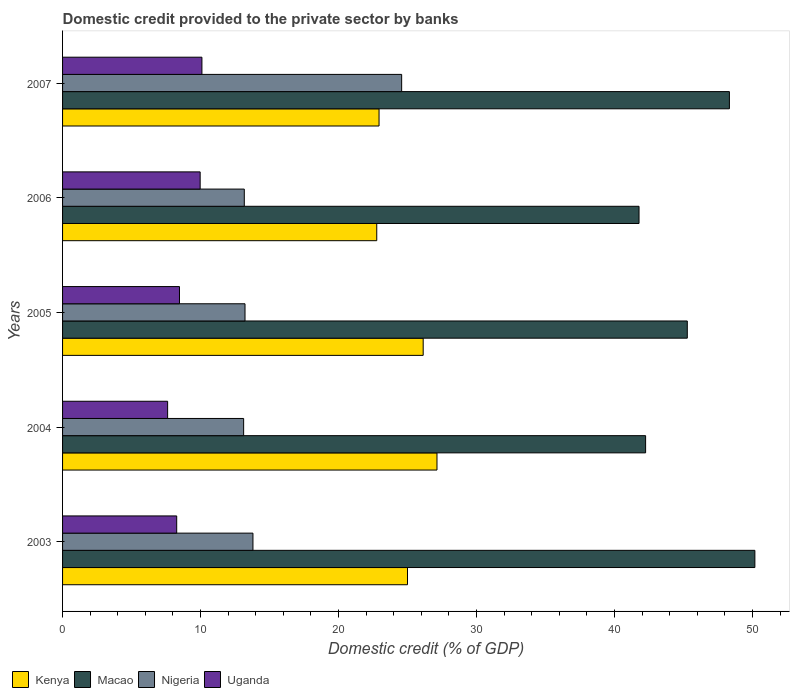How many bars are there on the 3rd tick from the top?
Ensure brevity in your answer.  4. How many bars are there on the 5th tick from the bottom?
Your answer should be very brief. 4. What is the domestic credit provided to the private sector by banks in Macao in 2004?
Ensure brevity in your answer.  42.25. Across all years, what is the maximum domestic credit provided to the private sector by banks in Macao?
Provide a succinct answer. 50.17. Across all years, what is the minimum domestic credit provided to the private sector by banks in Uganda?
Offer a terse response. 7.61. What is the total domestic credit provided to the private sector by banks in Nigeria in the graph?
Provide a succinct answer. 77.88. What is the difference between the domestic credit provided to the private sector by banks in Kenya in 2003 and that in 2005?
Offer a terse response. -1.14. What is the difference between the domestic credit provided to the private sector by banks in Uganda in 2006 and the domestic credit provided to the private sector by banks in Nigeria in 2007?
Your answer should be compact. -14.6. What is the average domestic credit provided to the private sector by banks in Nigeria per year?
Offer a terse response. 15.58. In the year 2004, what is the difference between the domestic credit provided to the private sector by banks in Nigeria and domestic credit provided to the private sector by banks in Kenya?
Provide a short and direct response. -14.01. In how many years, is the domestic credit provided to the private sector by banks in Kenya greater than 42 %?
Your answer should be compact. 0. What is the ratio of the domestic credit provided to the private sector by banks in Nigeria in 2005 to that in 2007?
Your answer should be compact. 0.54. What is the difference between the highest and the second highest domestic credit provided to the private sector by banks in Kenya?
Ensure brevity in your answer.  1. What is the difference between the highest and the lowest domestic credit provided to the private sector by banks in Uganda?
Provide a succinct answer. 2.49. In how many years, is the domestic credit provided to the private sector by banks in Kenya greater than the average domestic credit provided to the private sector by banks in Kenya taken over all years?
Your answer should be compact. 3. Is the sum of the domestic credit provided to the private sector by banks in Macao in 2005 and 2006 greater than the maximum domestic credit provided to the private sector by banks in Kenya across all years?
Keep it short and to the point. Yes. What does the 2nd bar from the top in 2003 represents?
Offer a terse response. Nigeria. What does the 3rd bar from the bottom in 2005 represents?
Your answer should be very brief. Nigeria. Is it the case that in every year, the sum of the domestic credit provided to the private sector by banks in Kenya and domestic credit provided to the private sector by banks in Uganda is greater than the domestic credit provided to the private sector by banks in Nigeria?
Offer a terse response. Yes. Are all the bars in the graph horizontal?
Provide a short and direct response. Yes. How many years are there in the graph?
Offer a terse response. 5. What is the difference between two consecutive major ticks on the X-axis?
Keep it short and to the point. 10. Does the graph contain grids?
Make the answer very short. No. How many legend labels are there?
Give a very brief answer. 4. How are the legend labels stacked?
Offer a very short reply. Horizontal. What is the title of the graph?
Make the answer very short. Domestic credit provided to the private sector by banks. What is the label or title of the X-axis?
Provide a succinct answer. Domestic credit (% of GDP). What is the Domestic credit (% of GDP) of Kenya in 2003?
Give a very brief answer. 24.99. What is the Domestic credit (% of GDP) in Macao in 2003?
Keep it short and to the point. 50.17. What is the Domestic credit (% of GDP) in Nigeria in 2003?
Offer a terse response. 13.8. What is the Domestic credit (% of GDP) in Uganda in 2003?
Your answer should be very brief. 8.27. What is the Domestic credit (% of GDP) of Kenya in 2004?
Offer a very short reply. 27.13. What is the Domestic credit (% of GDP) of Macao in 2004?
Ensure brevity in your answer.  42.25. What is the Domestic credit (% of GDP) of Nigeria in 2004?
Keep it short and to the point. 13.12. What is the Domestic credit (% of GDP) in Uganda in 2004?
Your answer should be very brief. 7.61. What is the Domestic credit (% of GDP) in Kenya in 2005?
Provide a short and direct response. 26.13. What is the Domestic credit (% of GDP) in Macao in 2005?
Ensure brevity in your answer.  45.27. What is the Domestic credit (% of GDP) in Nigeria in 2005?
Your answer should be compact. 13.22. What is the Domestic credit (% of GDP) of Uganda in 2005?
Give a very brief answer. 8.47. What is the Domestic credit (% of GDP) of Kenya in 2006?
Your answer should be very brief. 22.77. What is the Domestic credit (% of GDP) of Macao in 2006?
Your answer should be compact. 41.77. What is the Domestic credit (% of GDP) of Nigeria in 2006?
Make the answer very short. 13.17. What is the Domestic credit (% of GDP) of Uganda in 2006?
Keep it short and to the point. 9.97. What is the Domestic credit (% of GDP) of Kenya in 2007?
Keep it short and to the point. 22.93. What is the Domestic credit (% of GDP) of Macao in 2007?
Give a very brief answer. 48.32. What is the Domestic credit (% of GDP) in Nigeria in 2007?
Your response must be concise. 24.57. What is the Domestic credit (% of GDP) of Uganda in 2007?
Offer a terse response. 10.1. Across all years, what is the maximum Domestic credit (% of GDP) of Kenya?
Ensure brevity in your answer.  27.13. Across all years, what is the maximum Domestic credit (% of GDP) in Macao?
Provide a short and direct response. 50.17. Across all years, what is the maximum Domestic credit (% of GDP) of Nigeria?
Make the answer very short. 24.57. Across all years, what is the maximum Domestic credit (% of GDP) of Uganda?
Provide a succinct answer. 10.1. Across all years, what is the minimum Domestic credit (% of GDP) in Kenya?
Provide a succinct answer. 22.77. Across all years, what is the minimum Domestic credit (% of GDP) of Macao?
Offer a very short reply. 41.77. Across all years, what is the minimum Domestic credit (% of GDP) of Nigeria?
Your response must be concise. 13.12. Across all years, what is the minimum Domestic credit (% of GDP) in Uganda?
Provide a succinct answer. 7.61. What is the total Domestic credit (% of GDP) of Kenya in the graph?
Provide a succinct answer. 123.96. What is the total Domestic credit (% of GDP) in Macao in the graph?
Offer a terse response. 227.78. What is the total Domestic credit (% of GDP) of Nigeria in the graph?
Your response must be concise. 77.88. What is the total Domestic credit (% of GDP) in Uganda in the graph?
Provide a short and direct response. 44.42. What is the difference between the Domestic credit (% of GDP) of Kenya in 2003 and that in 2004?
Keep it short and to the point. -2.14. What is the difference between the Domestic credit (% of GDP) of Macao in 2003 and that in 2004?
Your answer should be very brief. 7.92. What is the difference between the Domestic credit (% of GDP) in Nigeria in 2003 and that in 2004?
Offer a very short reply. 0.68. What is the difference between the Domestic credit (% of GDP) in Uganda in 2003 and that in 2004?
Offer a very short reply. 0.66. What is the difference between the Domestic credit (% of GDP) in Kenya in 2003 and that in 2005?
Give a very brief answer. -1.14. What is the difference between the Domestic credit (% of GDP) of Macao in 2003 and that in 2005?
Your response must be concise. 4.9. What is the difference between the Domestic credit (% of GDP) of Nigeria in 2003 and that in 2005?
Your answer should be compact. 0.58. What is the difference between the Domestic credit (% of GDP) in Uganda in 2003 and that in 2005?
Provide a succinct answer. -0.2. What is the difference between the Domestic credit (% of GDP) in Kenya in 2003 and that in 2006?
Your response must be concise. 2.23. What is the difference between the Domestic credit (% of GDP) in Macao in 2003 and that in 2006?
Keep it short and to the point. 8.39. What is the difference between the Domestic credit (% of GDP) in Nigeria in 2003 and that in 2006?
Ensure brevity in your answer.  0.63. What is the difference between the Domestic credit (% of GDP) in Uganda in 2003 and that in 2006?
Make the answer very short. -1.7. What is the difference between the Domestic credit (% of GDP) of Kenya in 2003 and that in 2007?
Make the answer very short. 2.06. What is the difference between the Domestic credit (% of GDP) of Macao in 2003 and that in 2007?
Provide a short and direct response. 1.85. What is the difference between the Domestic credit (% of GDP) in Nigeria in 2003 and that in 2007?
Give a very brief answer. -10.78. What is the difference between the Domestic credit (% of GDP) of Uganda in 2003 and that in 2007?
Ensure brevity in your answer.  -1.83. What is the difference between the Domestic credit (% of GDP) in Macao in 2004 and that in 2005?
Your answer should be very brief. -3.02. What is the difference between the Domestic credit (% of GDP) of Nigeria in 2004 and that in 2005?
Offer a terse response. -0.1. What is the difference between the Domestic credit (% of GDP) of Uganda in 2004 and that in 2005?
Keep it short and to the point. -0.86. What is the difference between the Domestic credit (% of GDP) of Kenya in 2004 and that in 2006?
Make the answer very short. 4.36. What is the difference between the Domestic credit (% of GDP) in Macao in 2004 and that in 2006?
Your response must be concise. 0.48. What is the difference between the Domestic credit (% of GDP) in Nigeria in 2004 and that in 2006?
Provide a succinct answer. -0.05. What is the difference between the Domestic credit (% of GDP) of Uganda in 2004 and that in 2006?
Give a very brief answer. -2.36. What is the difference between the Domestic credit (% of GDP) of Kenya in 2004 and that in 2007?
Provide a succinct answer. 4.2. What is the difference between the Domestic credit (% of GDP) in Macao in 2004 and that in 2007?
Your answer should be compact. -6.07. What is the difference between the Domestic credit (% of GDP) of Nigeria in 2004 and that in 2007?
Your answer should be very brief. -11.45. What is the difference between the Domestic credit (% of GDP) in Uganda in 2004 and that in 2007?
Provide a short and direct response. -2.49. What is the difference between the Domestic credit (% of GDP) in Kenya in 2005 and that in 2006?
Keep it short and to the point. 3.36. What is the difference between the Domestic credit (% of GDP) in Macao in 2005 and that in 2006?
Make the answer very short. 3.5. What is the difference between the Domestic credit (% of GDP) in Nigeria in 2005 and that in 2006?
Offer a very short reply. 0.05. What is the difference between the Domestic credit (% of GDP) in Uganda in 2005 and that in 2006?
Your answer should be very brief. -1.5. What is the difference between the Domestic credit (% of GDP) in Kenya in 2005 and that in 2007?
Give a very brief answer. 3.2. What is the difference between the Domestic credit (% of GDP) of Macao in 2005 and that in 2007?
Offer a very short reply. -3.05. What is the difference between the Domestic credit (% of GDP) in Nigeria in 2005 and that in 2007?
Offer a very short reply. -11.35. What is the difference between the Domestic credit (% of GDP) in Uganda in 2005 and that in 2007?
Offer a terse response. -1.63. What is the difference between the Domestic credit (% of GDP) of Kenya in 2006 and that in 2007?
Give a very brief answer. -0.17. What is the difference between the Domestic credit (% of GDP) of Macao in 2006 and that in 2007?
Your answer should be very brief. -6.55. What is the difference between the Domestic credit (% of GDP) of Nigeria in 2006 and that in 2007?
Your answer should be compact. -11.4. What is the difference between the Domestic credit (% of GDP) in Uganda in 2006 and that in 2007?
Ensure brevity in your answer.  -0.13. What is the difference between the Domestic credit (% of GDP) of Kenya in 2003 and the Domestic credit (% of GDP) of Macao in 2004?
Your answer should be very brief. -17.25. What is the difference between the Domestic credit (% of GDP) in Kenya in 2003 and the Domestic credit (% of GDP) in Nigeria in 2004?
Offer a very short reply. 11.87. What is the difference between the Domestic credit (% of GDP) of Kenya in 2003 and the Domestic credit (% of GDP) of Uganda in 2004?
Ensure brevity in your answer.  17.38. What is the difference between the Domestic credit (% of GDP) in Macao in 2003 and the Domestic credit (% of GDP) in Nigeria in 2004?
Make the answer very short. 37.05. What is the difference between the Domestic credit (% of GDP) in Macao in 2003 and the Domestic credit (% of GDP) in Uganda in 2004?
Offer a terse response. 42.55. What is the difference between the Domestic credit (% of GDP) of Nigeria in 2003 and the Domestic credit (% of GDP) of Uganda in 2004?
Give a very brief answer. 6.18. What is the difference between the Domestic credit (% of GDP) of Kenya in 2003 and the Domestic credit (% of GDP) of Macao in 2005?
Provide a succinct answer. -20.28. What is the difference between the Domestic credit (% of GDP) of Kenya in 2003 and the Domestic credit (% of GDP) of Nigeria in 2005?
Offer a terse response. 11.77. What is the difference between the Domestic credit (% of GDP) in Kenya in 2003 and the Domestic credit (% of GDP) in Uganda in 2005?
Your answer should be very brief. 16.52. What is the difference between the Domestic credit (% of GDP) in Macao in 2003 and the Domestic credit (% of GDP) in Nigeria in 2005?
Your answer should be compact. 36.95. What is the difference between the Domestic credit (% of GDP) in Macao in 2003 and the Domestic credit (% of GDP) in Uganda in 2005?
Ensure brevity in your answer.  41.69. What is the difference between the Domestic credit (% of GDP) in Nigeria in 2003 and the Domestic credit (% of GDP) in Uganda in 2005?
Keep it short and to the point. 5.32. What is the difference between the Domestic credit (% of GDP) of Kenya in 2003 and the Domestic credit (% of GDP) of Macao in 2006?
Provide a short and direct response. -16.78. What is the difference between the Domestic credit (% of GDP) in Kenya in 2003 and the Domestic credit (% of GDP) in Nigeria in 2006?
Provide a short and direct response. 11.83. What is the difference between the Domestic credit (% of GDP) in Kenya in 2003 and the Domestic credit (% of GDP) in Uganda in 2006?
Make the answer very short. 15.02. What is the difference between the Domestic credit (% of GDP) in Macao in 2003 and the Domestic credit (% of GDP) in Nigeria in 2006?
Provide a succinct answer. 37. What is the difference between the Domestic credit (% of GDP) of Macao in 2003 and the Domestic credit (% of GDP) of Uganda in 2006?
Provide a short and direct response. 40.2. What is the difference between the Domestic credit (% of GDP) of Nigeria in 2003 and the Domestic credit (% of GDP) of Uganda in 2006?
Your answer should be very brief. 3.83. What is the difference between the Domestic credit (% of GDP) of Kenya in 2003 and the Domestic credit (% of GDP) of Macao in 2007?
Provide a short and direct response. -23.33. What is the difference between the Domestic credit (% of GDP) in Kenya in 2003 and the Domestic credit (% of GDP) in Nigeria in 2007?
Ensure brevity in your answer.  0.42. What is the difference between the Domestic credit (% of GDP) of Kenya in 2003 and the Domestic credit (% of GDP) of Uganda in 2007?
Ensure brevity in your answer.  14.9. What is the difference between the Domestic credit (% of GDP) in Macao in 2003 and the Domestic credit (% of GDP) in Nigeria in 2007?
Your answer should be compact. 25.6. What is the difference between the Domestic credit (% of GDP) of Macao in 2003 and the Domestic credit (% of GDP) of Uganda in 2007?
Your answer should be compact. 40.07. What is the difference between the Domestic credit (% of GDP) of Nigeria in 2003 and the Domestic credit (% of GDP) of Uganda in 2007?
Ensure brevity in your answer.  3.7. What is the difference between the Domestic credit (% of GDP) of Kenya in 2004 and the Domestic credit (% of GDP) of Macao in 2005?
Provide a succinct answer. -18.14. What is the difference between the Domestic credit (% of GDP) in Kenya in 2004 and the Domestic credit (% of GDP) in Nigeria in 2005?
Keep it short and to the point. 13.91. What is the difference between the Domestic credit (% of GDP) of Kenya in 2004 and the Domestic credit (% of GDP) of Uganda in 2005?
Offer a terse response. 18.66. What is the difference between the Domestic credit (% of GDP) in Macao in 2004 and the Domestic credit (% of GDP) in Nigeria in 2005?
Offer a terse response. 29.03. What is the difference between the Domestic credit (% of GDP) of Macao in 2004 and the Domestic credit (% of GDP) of Uganda in 2005?
Make the answer very short. 33.78. What is the difference between the Domestic credit (% of GDP) of Nigeria in 2004 and the Domestic credit (% of GDP) of Uganda in 2005?
Offer a very short reply. 4.65. What is the difference between the Domestic credit (% of GDP) of Kenya in 2004 and the Domestic credit (% of GDP) of Macao in 2006?
Your answer should be very brief. -14.64. What is the difference between the Domestic credit (% of GDP) of Kenya in 2004 and the Domestic credit (% of GDP) of Nigeria in 2006?
Your answer should be very brief. 13.96. What is the difference between the Domestic credit (% of GDP) in Kenya in 2004 and the Domestic credit (% of GDP) in Uganda in 2006?
Your answer should be very brief. 17.16. What is the difference between the Domestic credit (% of GDP) of Macao in 2004 and the Domestic credit (% of GDP) of Nigeria in 2006?
Keep it short and to the point. 29.08. What is the difference between the Domestic credit (% of GDP) in Macao in 2004 and the Domestic credit (% of GDP) in Uganda in 2006?
Provide a short and direct response. 32.28. What is the difference between the Domestic credit (% of GDP) of Nigeria in 2004 and the Domestic credit (% of GDP) of Uganda in 2006?
Provide a succinct answer. 3.15. What is the difference between the Domestic credit (% of GDP) in Kenya in 2004 and the Domestic credit (% of GDP) in Macao in 2007?
Make the answer very short. -21.19. What is the difference between the Domestic credit (% of GDP) of Kenya in 2004 and the Domestic credit (% of GDP) of Nigeria in 2007?
Keep it short and to the point. 2.56. What is the difference between the Domestic credit (% of GDP) of Kenya in 2004 and the Domestic credit (% of GDP) of Uganda in 2007?
Your answer should be compact. 17.03. What is the difference between the Domestic credit (% of GDP) of Macao in 2004 and the Domestic credit (% of GDP) of Nigeria in 2007?
Offer a very short reply. 17.68. What is the difference between the Domestic credit (% of GDP) in Macao in 2004 and the Domestic credit (% of GDP) in Uganda in 2007?
Provide a succinct answer. 32.15. What is the difference between the Domestic credit (% of GDP) of Nigeria in 2004 and the Domestic credit (% of GDP) of Uganda in 2007?
Your answer should be compact. 3.02. What is the difference between the Domestic credit (% of GDP) of Kenya in 2005 and the Domestic credit (% of GDP) of Macao in 2006?
Give a very brief answer. -15.64. What is the difference between the Domestic credit (% of GDP) of Kenya in 2005 and the Domestic credit (% of GDP) of Nigeria in 2006?
Offer a very short reply. 12.96. What is the difference between the Domestic credit (% of GDP) in Kenya in 2005 and the Domestic credit (% of GDP) in Uganda in 2006?
Ensure brevity in your answer.  16.16. What is the difference between the Domestic credit (% of GDP) in Macao in 2005 and the Domestic credit (% of GDP) in Nigeria in 2006?
Offer a very short reply. 32.1. What is the difference between the Domestic credit (% of GDP) in Macao in 2005 and the Domestic credit (% of GDP) in Uganda in 2006?
Provide a succinct answer. 35.3. What is the difference between the Domestic credit (% of GDP) in Nigeria in 2005 and the Domestic credit (% of GDP) in Uganda in 2006?
Offer a terse response. 3.25. What is the difference between the Domestic credit (% of GDP) of Kenya in 2005 and the Domestic credit (% of GDP) of Macao in 2007?
Provide a succinct answer. -22.19. What is the difference between the Domestic credit (% of GDP) of Kenya in 2005 and the Domestic credit (% of GDP) of Nigeria in 2007?
Your answer should be very brief. 1.56. What is the difference between the Domestic credit (% of GDP) in Kenya in 2005 and the Domestic credit (% of GDP) in Uganda in 2007?
Offer a terse response. 16.03. What is the difference between the Domestic credit (% of GDP) of Macao in 2005 and the Domestic credit (% of GDP) of Nigeria in 2007?
Give a very brief answer. 20.7. What is the difference between the Domestic credit (% of GDP) of Macao in 2005 and the Domestic credit (% of GDP) of Uganda in 2007?
Provide a short and direct response. 35.17. What is the difference between the Domestic credit (% of GDP) of Nigeria in 2005 and the Domestic credit (% of GDP) of Uganda in 2007?
Provide a short and direct response. 3.12. What is the difference between the Domestic credit (% of GDP) of Kenya in 2006 and the Domestic credit (% of GDP) of Macao in 2007?
Offer a terse response. -25.55. What is the difference between the Domestic credit (% of GDP) of Kenya in 2006 and the Domestic credit (% of GDP) of Nigeria in 2007?
Make the answer very short. -1.8. What is the difference between the Domestic credit (% of GDP) in Kenya in 2006 and the Domestic credit (% of GDP) in Uganda in 2007?
Ensure brevity in your answer.  12.67. What is the difference between the Domestic credit (% of GDP) in Macao in 2006 and the Domestic credit (% of GDP) in Nigeria in 2007?
Your answer should be compact. 17.2. What is the difference between the Domestic credit (% of GDP) in Macao in 2006 and the Domestic credit (% of GDP) in Uganda in 2007?
Keep it short and to the point. 31.67. What is the difference between the Domestic credit (% of GDP) in Nigeria in 2006 and the Domestic credit (% of GDP) in Uganda in 2007?
Provide a succinct answer. 3.07. What is the average Domestic credit (% of GDP) of Kenya per year?
Provide a short and direct response. 24.79. What is the average Domestic credit (% of GDP) of Macao per year?
Give a very brief answer. 45.56. What is the average Domestic credit (% of GDP) of Nigeria per year?
Provide a short and direct response. 15.58. What is the average Domestic credit (% of GDP) of Uganda per year?
Offer a very short reply. 8.88. In the year 2003, what is the difference between the Domestic credit (% of GDP) of Kenya and Domestic credit (% of GDP) of Macao?
Make the answer very short. -25.17. In the year 2003, what is the difference between the Domestic credit (% of GDP) of Kenya and Domestic credit (% of GDP) of Nigeria?
Ensure brevity in your answer.  11.2. In the year 2003, what is the difference between the Domestic credit (% of GDP) of Kenya and Domestic credit (% of GDP) of Uganda?
Give a very brief answer. 16.72. In the year 2003, what is the difference between the Domestic credit (% of GDP) in Macao and Domestic credit (% of GDP) in Nigeria?
Ensure brevity in your answer.  36.37. In the year 2003, what is the difference between the Domestic credit (% of GDP) in Macao and Domestic credit (% of GDP) in Uganda?
Ensure brevity in your answer.  41.9. In the year 2003, what is the difference between the Domestic credit (% of GDP) of Nigeria and Domestic credit (% of GDP) of Uganda?
Make the answer very short. 5.53. In the year 2004, what is the difference between the Domestic credit (% of GDP) of Kenya and Domestic credit (% of GDP) of Macao?
Offer a very short reply. -15.12. In the year 2004, what is the difference between the Domestic credit (% of GDP) in Kenya and Domestic credit (% of GDP) in Nigeria?
Offer a terse response. 14.01. In the year 2004, what is the difference between the Domestic credit (% of GDP) in Kenya and Domestic credit (% of GDP) in Uganda?
Keep it short and to the point. 19.52. In the year 2004, what is the difference between the Domestic credit (% of GDP) in Macao and Domestic credit (% of GDP) in Nigeria?
Your answer should be very brief. 29.13. In the year 2004, what is the difference between the Domestic credit (% of GDP) in Macao and Domestic credit (% of GDP) in Uganda?
Ensure brevity in your answer.  34.64. In the year 2004, what is the difference between the Domestic credit (% of GDP) in Nigeria and Domestic credit (% of GDP) in Uganda?
Provide a short and direct response. 5.51. In the year 2005, what is the difference between the Domestic credit (% of GDP) of Kenya and Domestic credit (% of GDP) of Macao?
Provide a short and direct response. -19.14. In the year 2005, what is the difference between the Domestic credit (% of GDP) of Kenya and Domestic credit (% of GDP) of Nigeria?
Your response must be concise. 12.91. In the year 2005, what is the difference between the Domestic credit (% of GDP) of Kenya and Domestic credit (% of GDP) of Uganda?
Ensure brevity in your answer.  17.66. In the year 2005, what is the difference between the Domestic credit (% of GDP) of Macao and Domestic credit (% of GDP) of Nigeria?
Offer a very short reply. 32.05. In the year 2005, what is the difference between the Domestic credit (% of GDP) of Macao and Domestic credit (% of GDP) of Uganda?
Offer a terse response. 36.8. In the year 2005, what is the difference between the Domestic credit (% of GDP) of Nigeria and Domestic credit (% of GDP) of Uganda?
Give a very brief answer. 4.75. In the year 2006, what is the difference between the Domestic credit (% of GDP) in Kenya and Domestic credit (% of GDP) in Macao?
Your answer should be very brief. -19.01. In the year 2006, what is the difference between the Domestic credit (% of GDP) of Kenya and Domestic credit (% of GDP) of Nigeria?
Provide a succinct answer. 9.6. In the year 2006, what is the difference between the Domestic credit (% of GDP) in Kenya and Domestic credit (% of GDP) in Uganda?
Provide a succinct answer. 12.8. In the year 2006, what is the difference between the Domestic credit (% of GDP) in Macao and Domestic credit (% of GDP) in Nigeria?
Ensure brevity in your answer.  28.6. In the year 2006, what is the difference between the Domestic credit (% of GDP) in Macao and Domestic credit (% of GDP) in Uganda?
Provide a short and direct response. 31.8. In the year 2006, what is the difference between the Domestic credit (% of GDP) in Nigeria and Domestic credit (% of GDP) in Uganda?
Offer a very short reply. 3.2. In the year 2007, what is the difference between the Domestic credit (% of GDP) of Kenya and Domestic credit (% of GDP) of Macao?
Your response must be concise. -25.39. In the year 2007, what is the difference between the Domestic credit (% of GDP) in Kenya and Domestic credit (% of GDP) in Nigeria?
Keep it short and to the point. -1.64. In the year 2007, what is the difference between the Domestic credit (% of GDP) of Kenya and Domestic credit (% of GDP) of Uganda?
Keep it short and to the point. 12.83. In the year 2007, what is the difference between the Domestic credit (% of GDP) in Macao and Domestic credit (% of GDP) in Nigeria?
Provide a succinct answer. 23.75. In the year 2007, what is the difference between the Domestic credit (% of GDP) in Macao and Domestic credit (% of GDP) in Uganda?
Ensure brevity in your answer.  38.22. In the year 2007, what is the difference between the Domestic credit (% of GDP) in Nigeria and Domestic credit (% of GDP) in Uganda?
Keep it short and to the point. 14.47. What is the ratio of the Domestic credit (% of GDP) of Kenya in 2003 to that in 2004?
Provide a short and direct response. 0.92. What is the ratio of the Domestic credit (% of GDP) of Macao in 2003 to that in 2004?
Offer a terse response. 1.19. What is the ratio of the Domestic credit (% of GDP) in Nigeria in 2003 to that in 2004?
Your answer should be compact. 1.05. What is the ratio of the Domestic credit (% of GDP) of Uganda in 2003 to that in 2004?
Give a very brief answer. 1.09. What is the ratio of the Domestic credit (% of GDP) in Kenya in 2003 to that in 2005?
Provide a succinct answer. 0.96. What is the ratio of the Domestic credit (% of GDP) in Macao in 2003 to that in 2005?
Provide a succinct answer. 1.11. What is the ratio of the Domestic credit (% of GDP) in Nigeria in 2003 to that in 2005?
Give a very brief answer. 1.04. What is the ratio of the Domestic credit (% of GDP) in Uganda in 2003 to that in 2005?
Provide a short and direct response. 0.98. What is the ratio of the Domestic credit (% of GDP) in Kenya in 2003 to that in 2006?
Your answer should be compact. 1.1. What is the ratio of the Domestic credit (% of GDP) in Macao in 2003 to that in 2006?
Offer a very short reply. 1.2. What is the ratio of the Domestic credit (% of GDP) of Nigeria in 2003 to that in 2006?
Make the answer very short. 1.05. What is the ratio of the Domestic credit (% of GDP) in Uganda in 2003 to that in 2006?
Ensure brevity in your answer.  0.83. What is the ratio of the Domestic credit (% of GDP) in Kenya in 2003 to that in 2007?
Keep it short and to the point. 1.09. What is the ratio of the Domestic credit (% of GDP) of Macao in 2003 to that in 2007?
Give a very brief answer. 1.04. What is the ratio of the Domestic credit (% of GDP) of Nigeria in 2003 to that in 2007?
Make the answer very short. 0.56. What is the ratio of the Domestic credit (% of GDP) in Uganda in 2003 to that in 2007?
Make the answer very short. 0.82. What is the ratio of the Domestic credit (% of GDP) in Kenya in 2004 to that in 2005?
Offer a very short reply. 1.04. What is the ratio of the Domestic credit (% of GDP) of Macao in 2004 to that in 2005?
Give a very brief answer. 0.93. What is the ratio of the Domestic credit (% of GDP) in Uganda in 2004 to that in 2005?
Provide a short and direct response. 0.9. What is the ratio of the Domestic credit (% of GDP) in Kenya in 2004 to that in 2006?
Provide a succinct answer. 1.19. What is the ratio of the Domestic credit (% of GDP) of Macao in 2004 to that in 2006?
Offer a very short reply. 1.01. What is the ratio of the Domestic credit (% of GDP) of Nigeria in 2004 to that in 2006?
Your response must be concise. 1. What is the ratio of the Domestic credit (% of GDP) in Uganda in 2004 to that in 2006?
Ensure brevity in your answer.  0.76. What is the ratio of the Domestic credit (% of GDP) of Kenya in 2004 to that in 2007?
Ensure brevity in your answer.  1.18. What is the ratio of the Domestic credit (% of GDP) of Macao in 2004 to that in 2007?
Your answer should be very brief. 0.87. What is the ratio of the Domestic credit (% of GDP) of Nigeria in 2004 to that in 2007?
Your response must be concise. 0.53. What is the ratio of the Domestic credit (% of GDP) in Uganda in 2004 to that in 2007?
Your answer should be compact. 0.75. What is the ratio of the Domestic credit (% of GDP) of Kenya in 2005 to that in 2006?
Ensure brevity in your answer.  1.15. What is the ratio of the Domestic credit (% of GDP) of Macao in 2005 to that in 2006?
Your response must be concise. 1.08. What is the ratio of the Domestic credit (% of GDP) of Nigeria in 2005 to that in 2006?
Provide a short and direct response. 1. What is the ratio of the Domestic credit (% of GDP) of Uganda in 2005 to that in 2006?
Ensure brevity in your answer.  0.85. What is the ratio of the Domestic credit (% of GDP) in Kenya in 2005 to that in 2007?
Give a very brief answer. 1.14. What is the ratio of the Domestic credit (% of GDP) in Macao in 2005 to that in 2007?
Provide a short and direct response. 0.94. What is the ratio of the Domestic credit (% of GDP) in Nigeria in 2005 to that in 2007?
Provide a short and direct response. 0.54. What is the ratio of the Domestic credit (% of GDP) of Uganda in 2005 to that in 2007?
Keep it short and to the point. 0.84. What is the ratio of the Domestic credit (% of GDP) in Macao in 2006 to that in 2007?
Provide a succinct answer. 0.86. What is the ratio of the Domestic credit (% of GDP) of Nigeria in 2006 to that in 2007?
Offer a terse response. 0.54. What is the ratio of the Domestic credit (% of GDP) of Uganda in 2006 to that in 2007?
Ensure brevity in your answer.  0.99. What is the difference between the highest and the second highest Domestic credit (% of GDP) in Macao?
Provide a short and direct response. 1.85. What is the difference between the highest and the second highest Domestic credit (% of GDP) of Nigeria?
Your answer should be very brief. 10.78. What is the difference between the highest and the second highest Domestic credit (% of GDP) in Uganda?
Provide a succinct answer. 0.13. What is the difference between the highest and the lowest Domestic credit (% of GDP) in Kenya?
Your answer should be compact. 4.36. What is the difference between the highest and the lowest Domestic credit (% of GDP) of Macao?
Provide a short and direct response. 8.39. What is the difference between the highest and the lowest Domestic credit (% of GDP) of Nigeria?
Keep it short and to the point. 11.45. What is the difference between the highest and the lowest Domestic credit (% of GDP) of Uganda?
Provide a succinct answer. 2.49. 